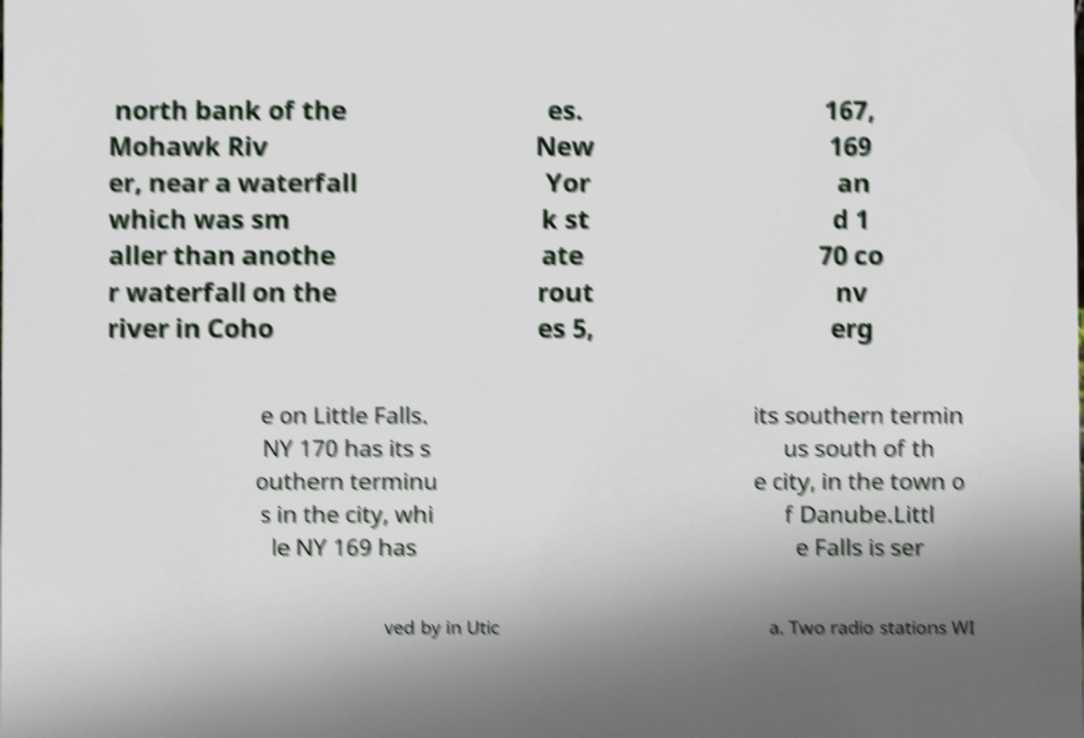Please identify and transcribe the text found in this image. north bank of the Mohawk Riv er, near a waterfall which was sm aller than anothe r waterfall on the river in Coho es. New Yor k st ate rout es 5, 167, 169 an d 1 70 co nv erg e on Little Falls. NY 170 has its s outhern terminu s in the city, whi le NY 169 has its southern termin us south of th e city, in the town o f Danube.Littl e Falls is ser ved by in Utic a. Two radio stations WI 